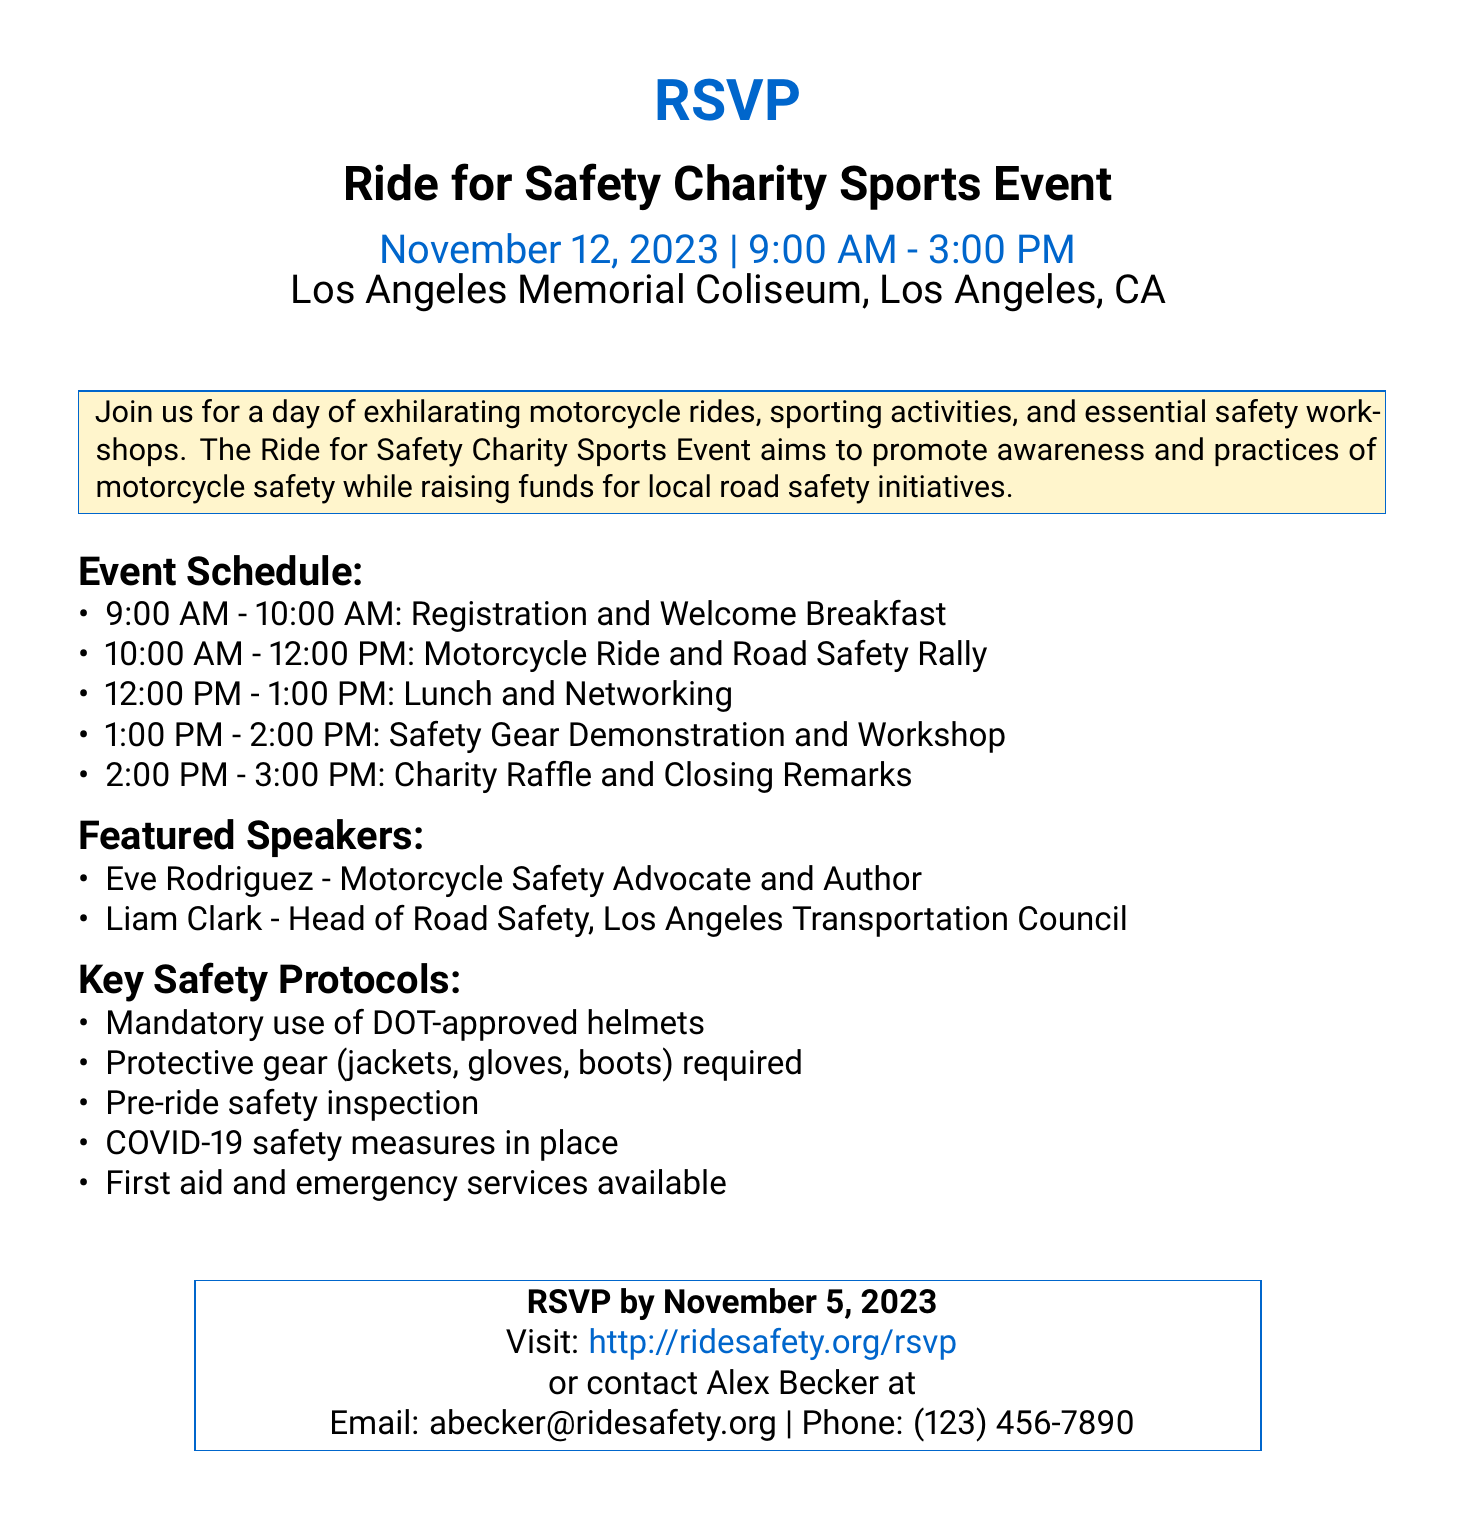What is the date of the event? The date is explicitly mentioned as November 12, 2023.
Answer: November 12, 2023 What time does the event start? The event schedule shows that it starts at 9:00 AM.
Answer: 9:00 AM Who is the head of the Road Safety organization? The document lists Liam Clark as the Head of Road Safety, Los Angeles Transportation Council.
Answer: Liam Clark What is required for participation in the ride? Key safety protocols state that DOT-approved helmets must be worn.
Answer: DOT-approved helmets How long is the motorcycle ride scheduled for? The schedule shows the motorcycle ride lasts from 10:00 AM to 12:00 PM, which is 2 hours.
Answer: 2 hours What is the purpose of the event? The event aims to promote awareness and practices of motorcycle safety while raising funds for local initiatives.
Answer: Promote awareness and raise funds When is the RSVP deadline? The RSVP deadline is stated as November 5, 2023.
Answer: November 5, 2023 What will be a featured activity during the event? One of the activities listed is the Safety Gear Demonstration and Workshop.
Answer: Safety Gear Demonstration and Workshop Who can be contacted for more information? The contact person listed is Alex Becker with email abecker@ridesafety.org.
Answer: Alex Becker, abecker@ridesafety.org 